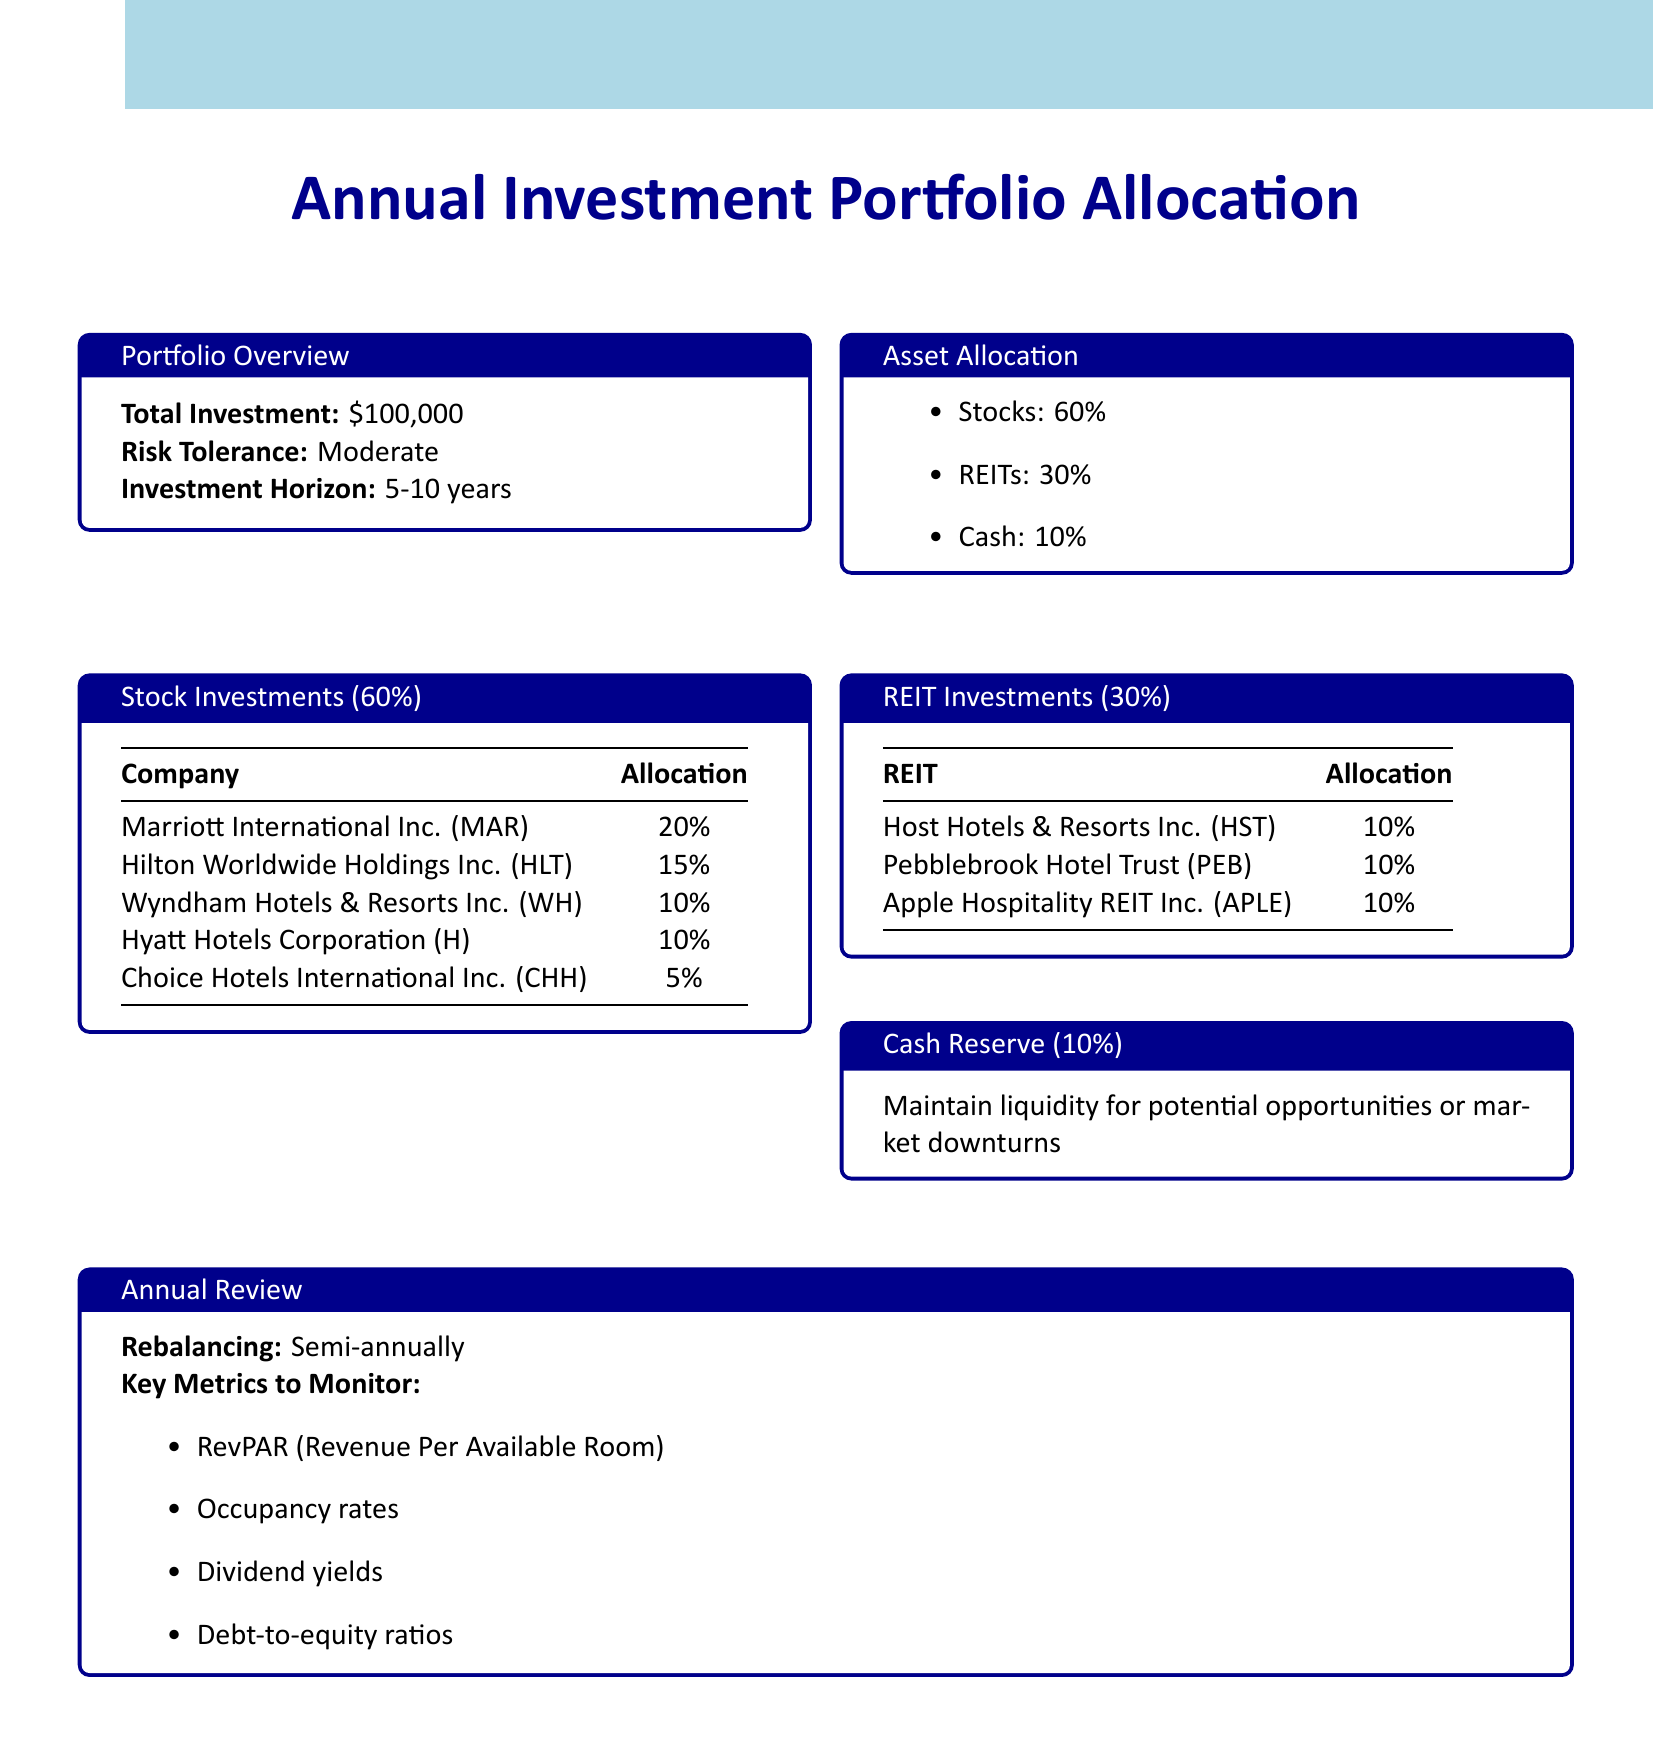what is the total investment? The total investment is stated in the document as $100,000.
Answer: $100,000 what is the risk tolerance level? The risk tolerance level is mentioned as Moderate in the portfolio overview.
Answer: Moderate how much is allocated to stocks? The document specifies that 60% of the investment is allocated to stocks.
Answer: 60% who is allocated the most in stock investments? The stock investment allocation indicates that Marriott International Inc. (MAR) has the highest allocation at 20%.
Answer: Marriott International Inc. (MAR) what percentage of the portfolio is allocated to cash? The cash allocation is noted as 10% in the asset allocation section of the document.
Answer: 10% which REIT has the lowest allocation? The REIT investments section reveals that all listed REITs have an equal allocation of 10%, but since there's no distinction, it's ambiguous; each has the same percentage.
Answer: All equal at 10% how often is rebalancing scheduled? The annual review section clearly states that rebalancing occurs semi-annually.
Answer: Semi-annually which metric is listed to monitor alongside RevPAR? The document lists occupancy rates as a key metric alongside RevPAR.
Answer: Occupancy rates what is the investment horizon? The investment horizon is defined as 5-10 years in the portfolio overview section.
Answer: 5-10 years 